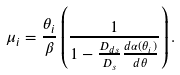<formula> <loc_0><loc_0><loc_500><loc_500>\mu _ { i } = \frac { \theta _ { i } } { \beta } \left ( \frac { 1 } { 1 - \frac { D _ { d s } } { D _ { s } } \frac { d \alpha ( \theta _ { i } ) } { d \theta } } \right ) .</formula> 